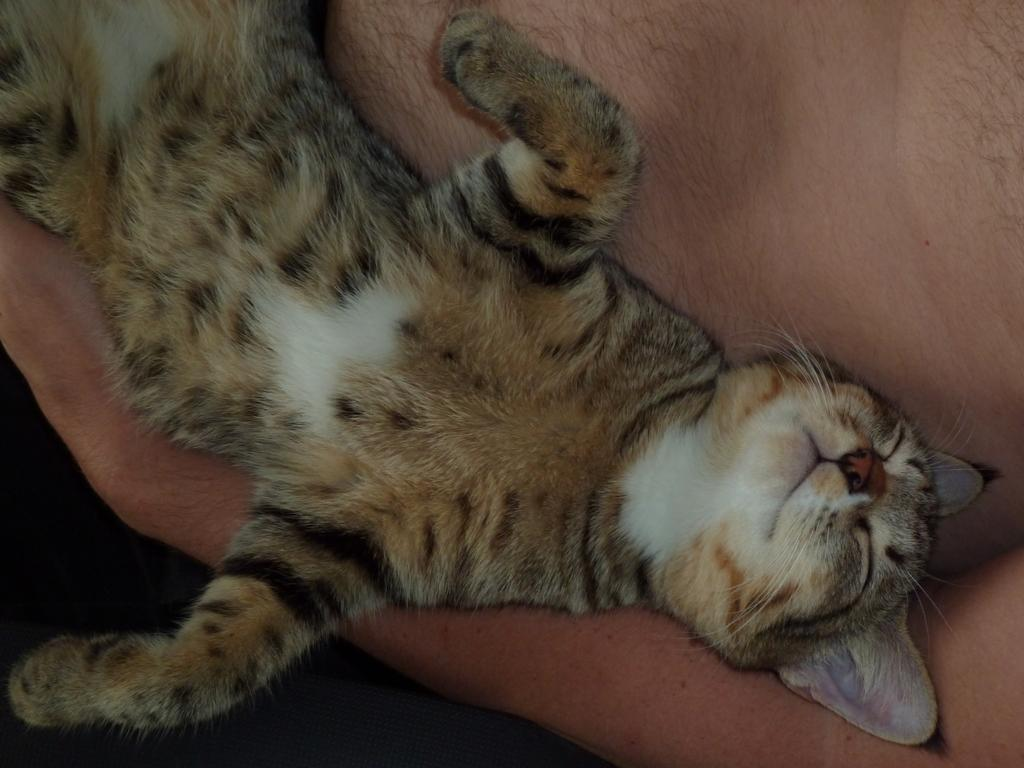What type of animal is in the image? There is a cat in the image. Where is the cat located in the image? The cat is on a person's body. What type of tool is the fireman using in the image? There is no fireman or tool present in the image; it only features a cat on a person's body. What type of pencil is the carpenter using in the image? There is no carpenter or pencil present in the image; it only features a cat on a person's body. 